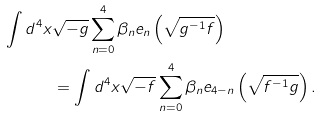<formula> <loc_0><loc_0><loc_500><loc_500>\int d ^ { 4 } x & \sqrt { - g } \sum ^ { 4 } _ { n = 0 } \beta _ { n } e _ { n } \left ( \sqrt { g ^ { - 1 } f } \right ) \\ & = \int d ^ { 4 } x \sqrt { - f } \sum ^ { 4 } _ { n = 0 } \beta _ { n } e _ { 4 - n } \left ( \sqrt { f ^ { - 1 } g } \right ) .</formula> 